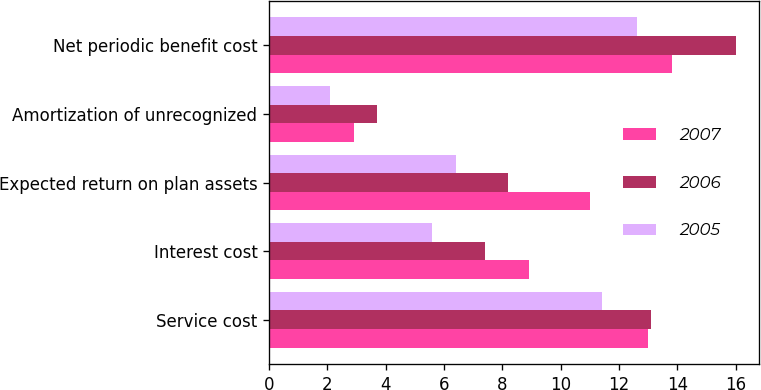Convert chart. <chart><loc_0><loc_0><loc_500><loc_500><stacked_bar_chart><ecel><fcel>Service cost<fcel>Interest cost<fcel>Expected return on plan assets<fcel>Amortization of unrecognized<fcel>Net periodic benefit cost<nl><fcel>2007<fcel>13<fcel>8.9<fcel>11<fcel>2.9<fcel>13.8<nl><fcel>2006<fcel>13.1<fcel>7.4<fcel>8.2<fcel>3.7<fcel>16<nl><fcel>2005<fcel>11.4<fcel>5.6<fcel>6.4<fcel>2.1<fcel>12.6<nl></chart> 